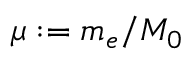<formula> <loc_0><loc_0><loc_500><loc_500>\mu \colon = m _ { e } / M _ { 0 }</formula> 